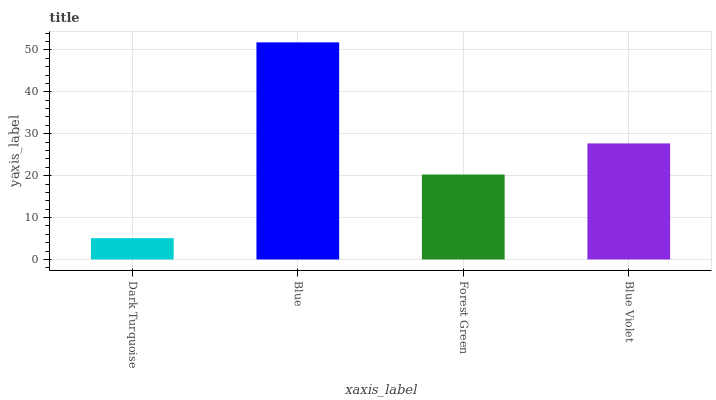Is Dark Turquoise the minimum?
Answer yes or no. Yes. Is Blue the maximum?
Answer yes or no. Yes. Is Forest Green the minimum?
Answer yes or no. No. Is Forest Green the maximum?
Answer yes or no. No. Is Blue greater than Forest Green?
Answer yes or no. Yes. Is Forest Green less than Blue?
Answer yes or no. Yes. Is Forest Green greater than Blue?
Answer yes or no. No. Is Blue less than Forest Green?
Answer yes or no. No. Is Blue Violet the high median?
Answer yes or no. Yes. Is Forest Green the low median?
Answer yes or no. Yes. Is Dark Turquoise the high median?
Answer yes or no. No. Is Blue the low median?
Answer yes or no. No. 